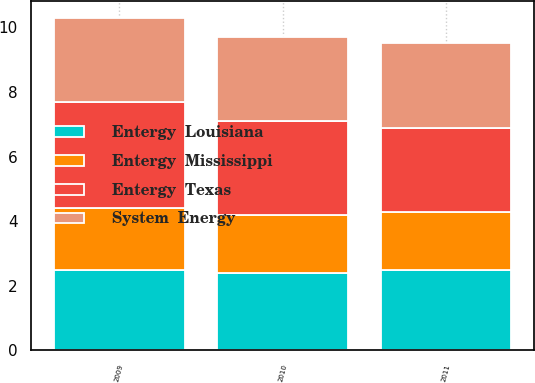Convert chart to OTSL. <chart><loc_0><loc_0><loc_500><loc_500><stacked_bar_chart><ecel><fcel>2011<fcel>2010<fcel>2009<nl><fcel>Entergy  Texas<fcel>2.6<fcel>2.9<fcel>3.3<nl><fcel>Entergy  Mississippi<fcel>1.8<fcel>1.8<fcel>1.9<nl><fcel>Entergy  Louisiana<fcel>2.5<fcel>2.4<fcel>2.5<nl><fcel>System  Energy<fcel>2.6<fcel>2.6<fcel>2.6<nl></chart> 